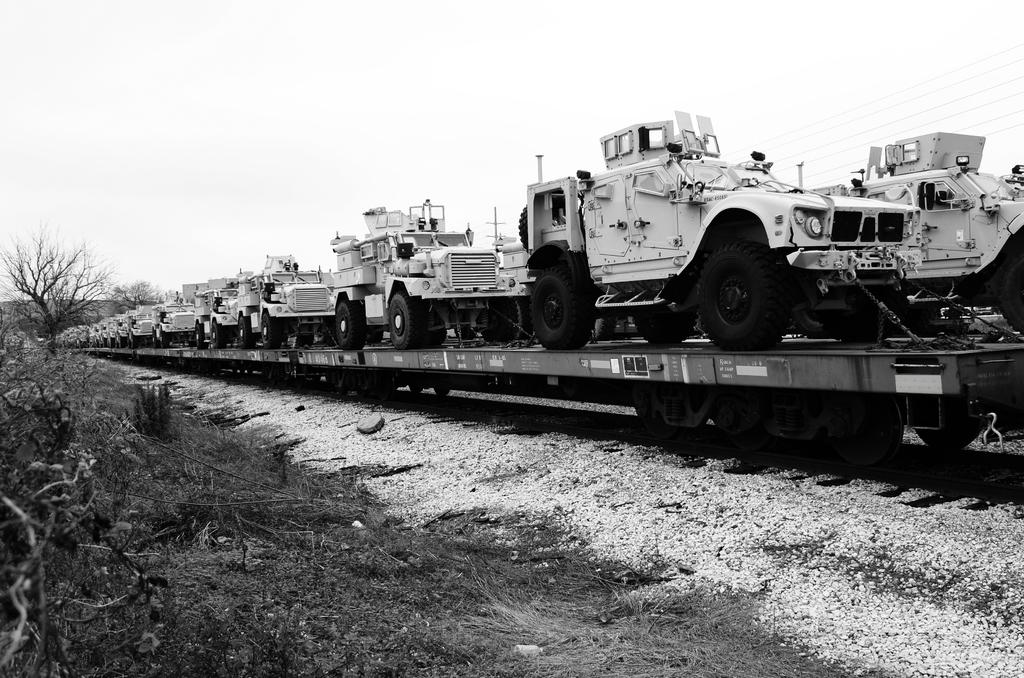What is the color scheme of the image? The image is black and white. What is the setting of the image? The image depicts a train platform. What type of vehicles can be seen on the train platform? There are vehicles on the train platform. What type of vegetation is visible in the image? Bare trees are visible in the image. What is the cause of the protest happening on the train platform in the image? There is no protest present in the image; it depicts a train platform with vehicles and bare trees. What is the source of fear for the people on the train platform in the image? There is no indication of fear or any specific situation that might cause fear in the image. 